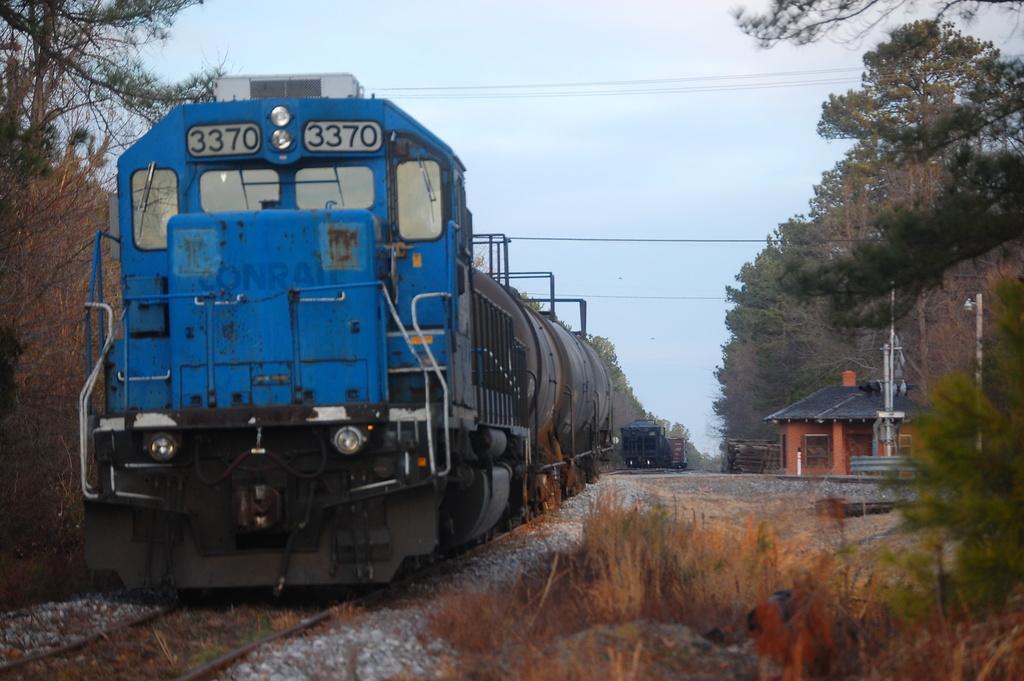Could you give a brief overview of what you see in this image? In this image we can see two trains, grass and some trees at the right we can see house and electrical pole. 